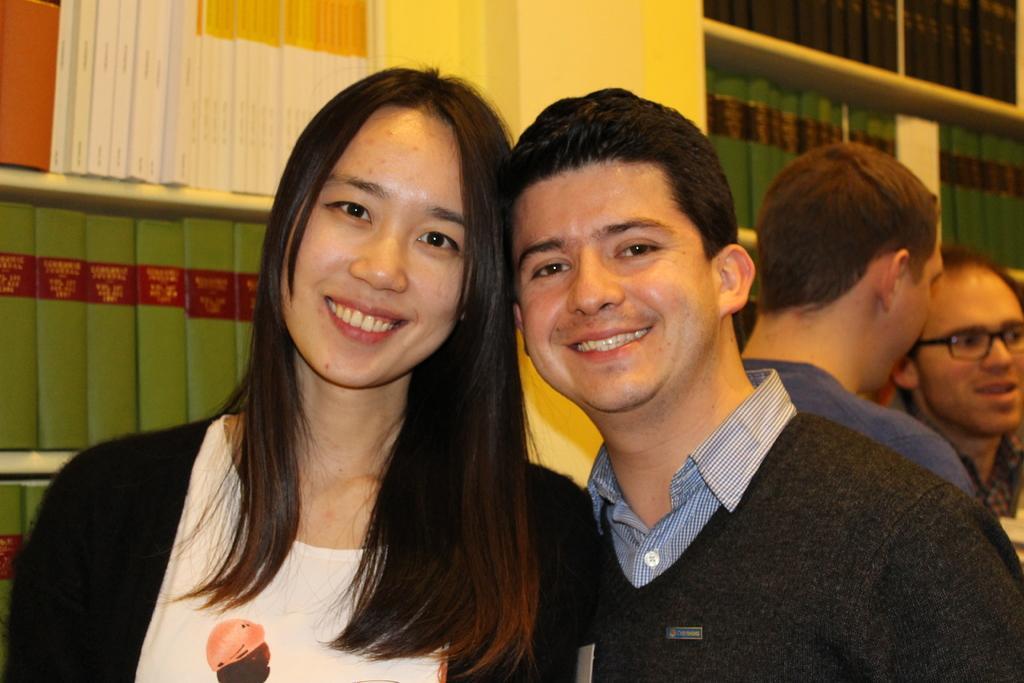Please provide a concise description of this image. In the foreground of the picture there is a woman and a man. On the left there are books in bookshelves. On the right there are two men standing and talking. On the top there are books in bookshelves. In the center of the background it is well. 